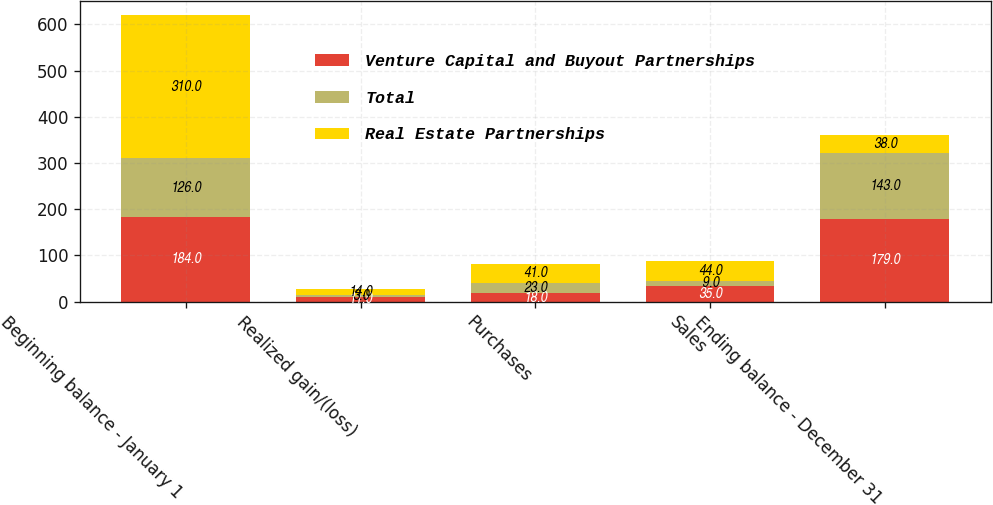<chart> <loc_0><loc_0><loc_500><loc_500><stacked_bar_chart><ecel><fcel>Beginning balance - January 1<fcel>Realized gain/(loss)<fcel>Purchases<fcel>Sales<fcel>Ending balance - December 31<nl><fcel>Venture Capital and Buyout Partnerships<fcel>184<fcel>11<fcel>18<fcel>35<fcel>179<nl><fcel>Total<fcel>126<fcel>3<fcel>23<fcel>9<fcel>143<nl><fcel>Real Estate Partnerships<fcel>310<fcel>14<fcel>41<fcel>44<fcel>38<nl></chart> 